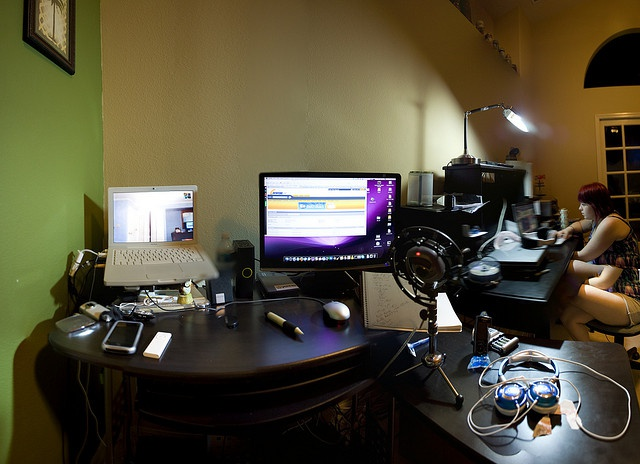Describe the objects in this image and their specific colors. I can see tv in darkgreen, white, black, navy, and purple tones, laptop in darkgreen, darkgray, white, and gray tones, tv in darkgreen, white, darkgray, and lavender tones, people in darkgreen, black, maroon, and gray tones, and clock in darkgreen, tan, and olive tones in this image. 